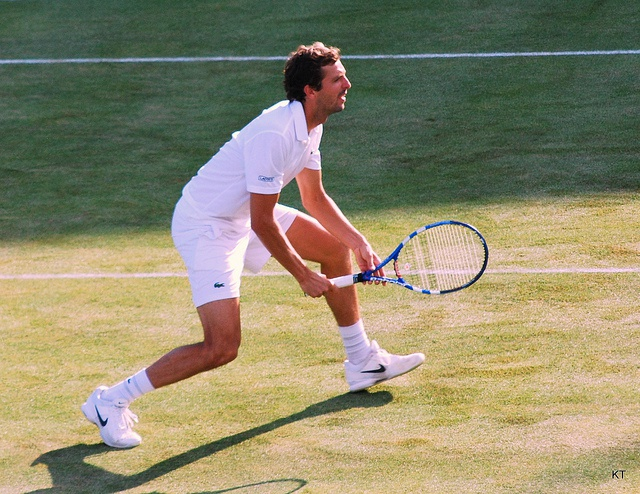Describe the objects in this image and their specific colors. I can see people in teal, lavender, and maroon tones and tennis racket in teal, pink, and tan tones in this image. 